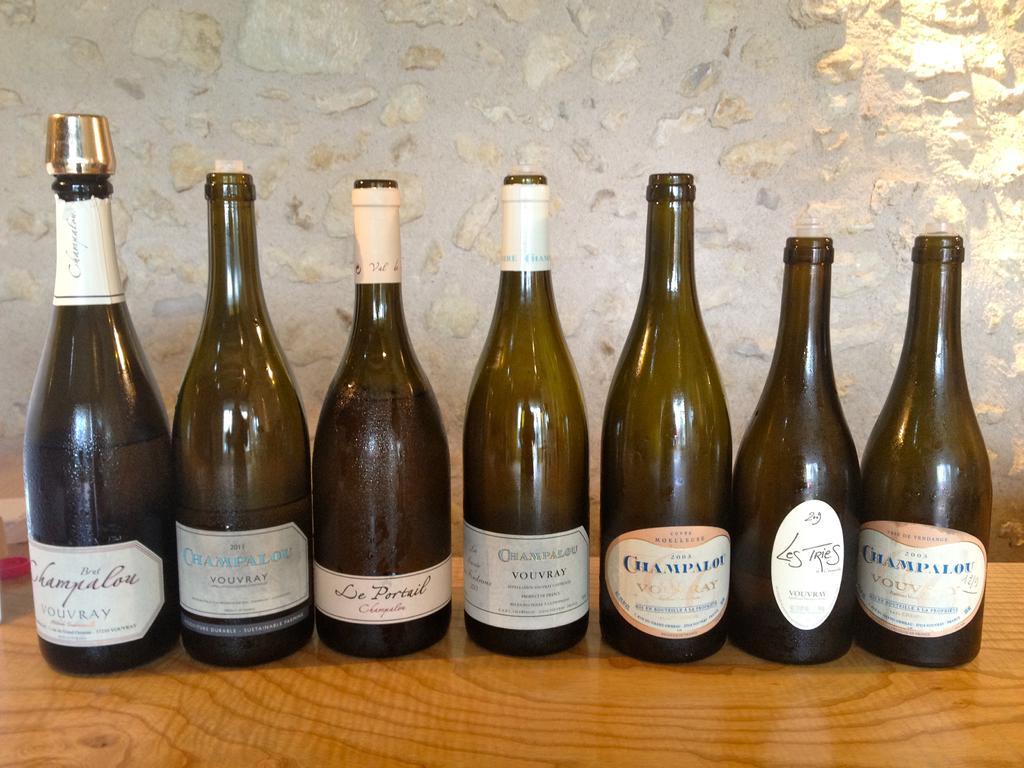Could you give a brief overview of what you see in this image? There are group of bottles kept on the table in this picture. In the background there is a white colour wall. 